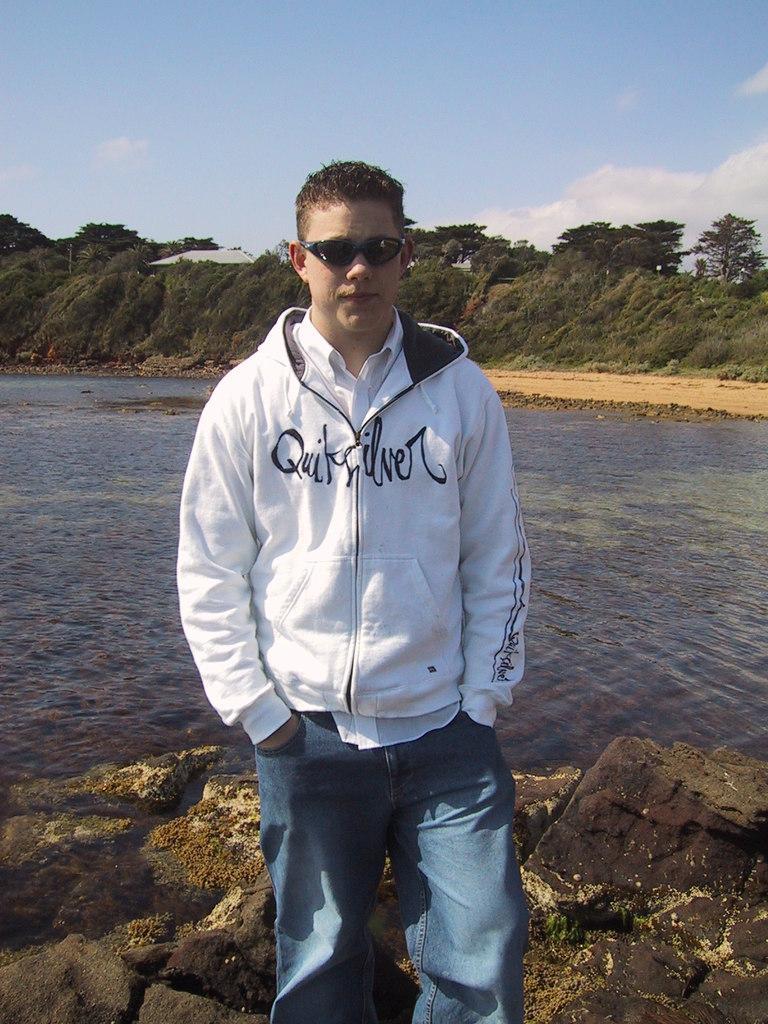Please provide a concise description of this image. In this picture I can see a man standing in front on the brown color surface and I see that, he is wearing a jacket, jeans and shades. In the middle of this picture I can see the water. In the background I can see number of trees and I can see the sky. 